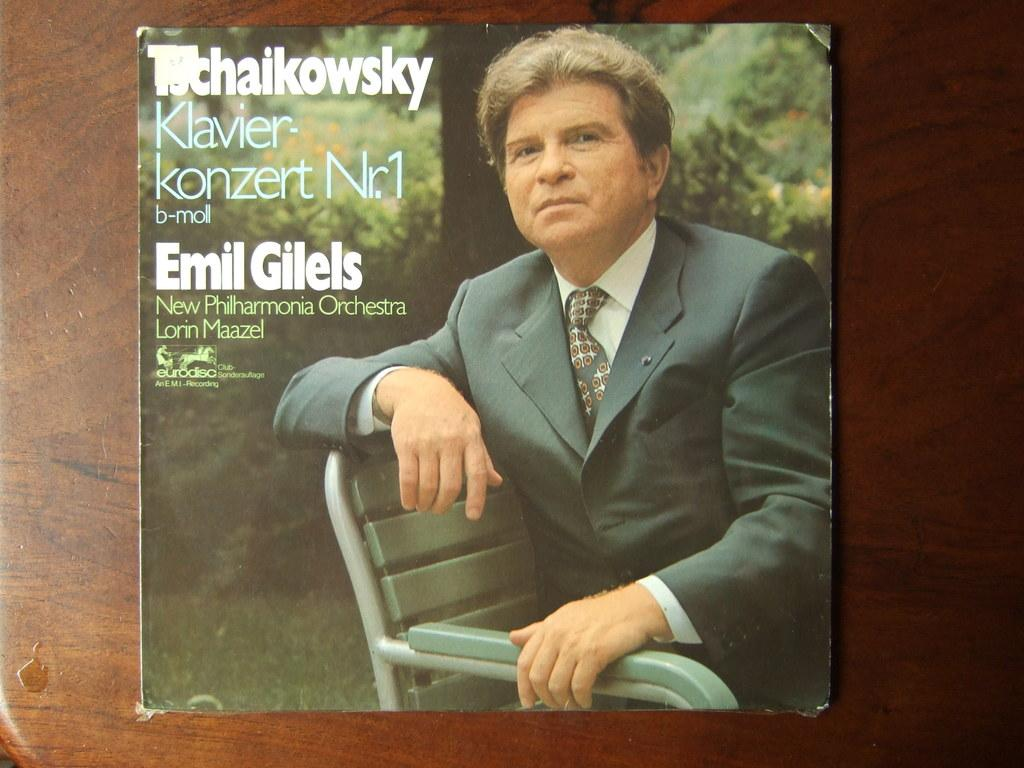What is the man in the image doing? The man is sitting on a chair in the image. What can be seen on the wooden surface in the image? There is a card on the wooden surface. What is visible in the background behind the man? Trees are visible behind the man. What is written on the card in the image? There is writing on the card. What type of pancake is being used as a base for the card in the image? There is no pancake present in the image; the card is on a wooden surface. 